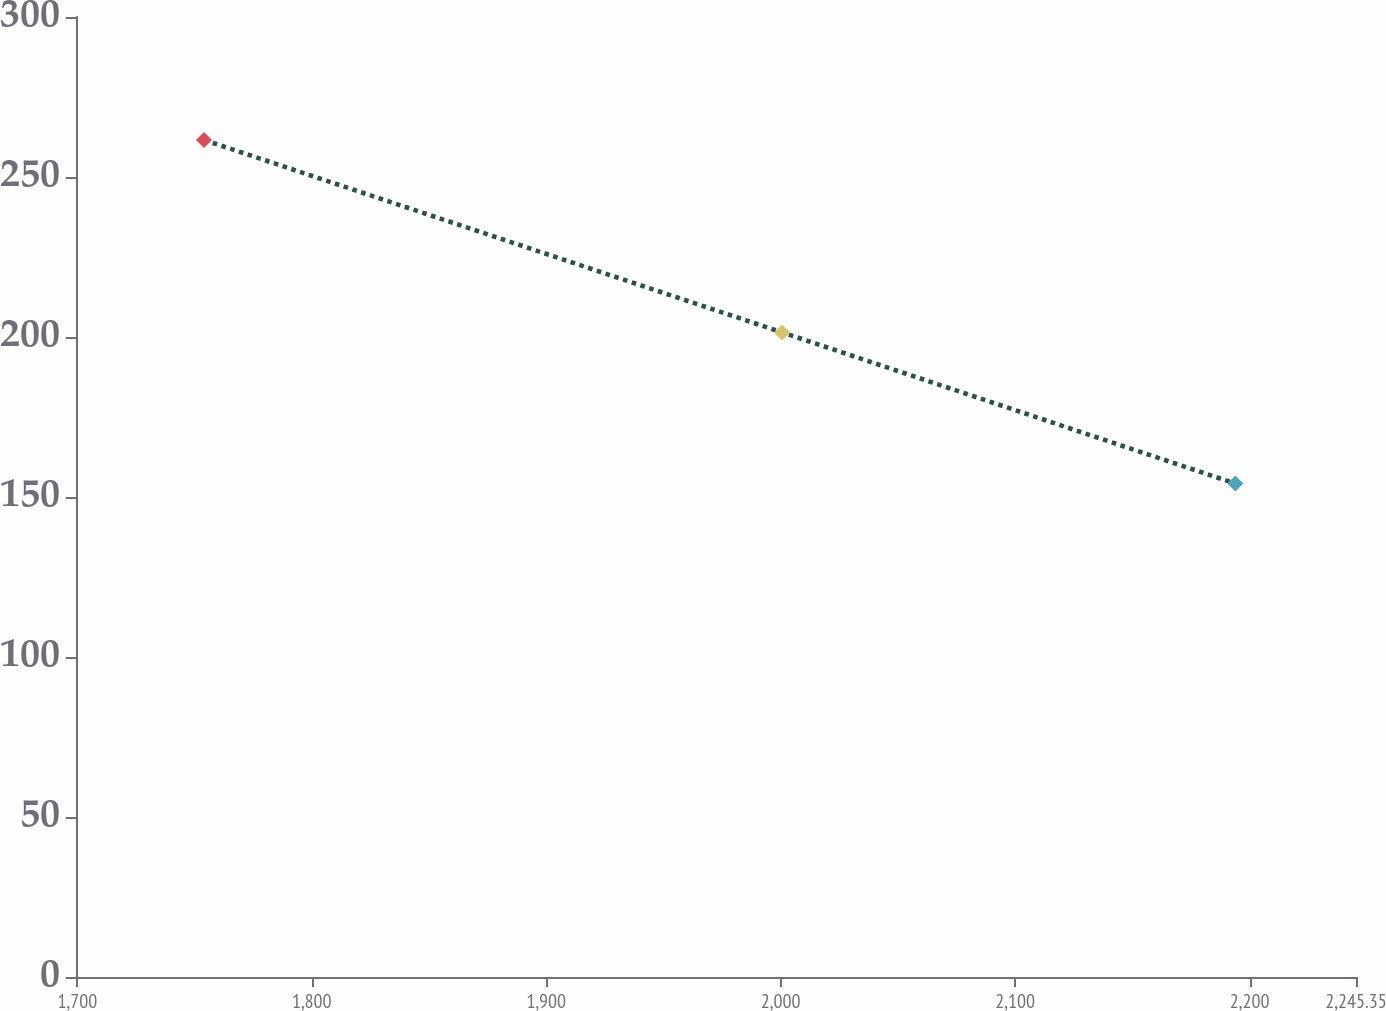<chart> <loc_0><loc_0><loc_500><loc_500><line_chart><ecel><fcel>$ 269<nl><fcel>1754.04<fcel>261.58<nl><fcel>2000.61<fcel>201.44<nl><fcel>2193.89<fcel>154.2<nl><fcel>2299.94<fcel>181.85<nl></chart> 